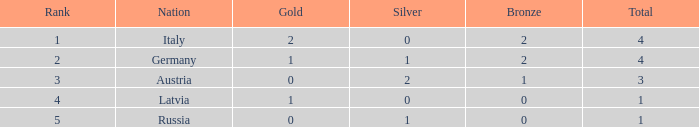What is the mean number of gold medals for nations with at least 1 bronze, at least 1 silver, a rank higher than 2, and a total medal count greater than 3? None. 